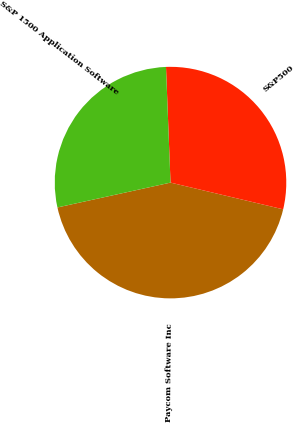Convert chart. <chart><loc_0><loc_0><loc_500><loc_500><pie_chart><fcel>Paycom Software Inc<fcel>S&P500<fcel>S&P 1500 Application Software<nl><fcel>42.85%<fcel>29.33%<fcel>27.82%<nl></chart> 